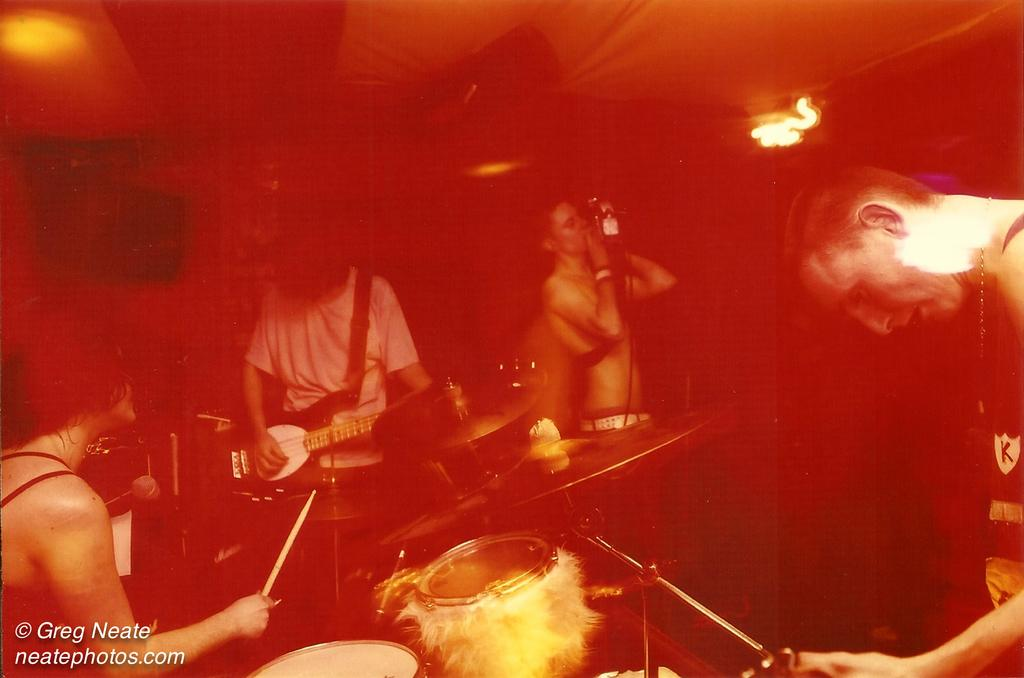How many people are in the image? There are four people in the image. What are the people in the image doing? Each person is playing a different musical instrument. What type of vegetable is being played as a musical instrument in the image? There are no vegetables being played as musical instruments in the image; each person is playing a different musical instrument. How many copies of the same musical instrument are being played in the image? There are no copies of the same musical instrument being played in the image; each person is playing a different instrument. 